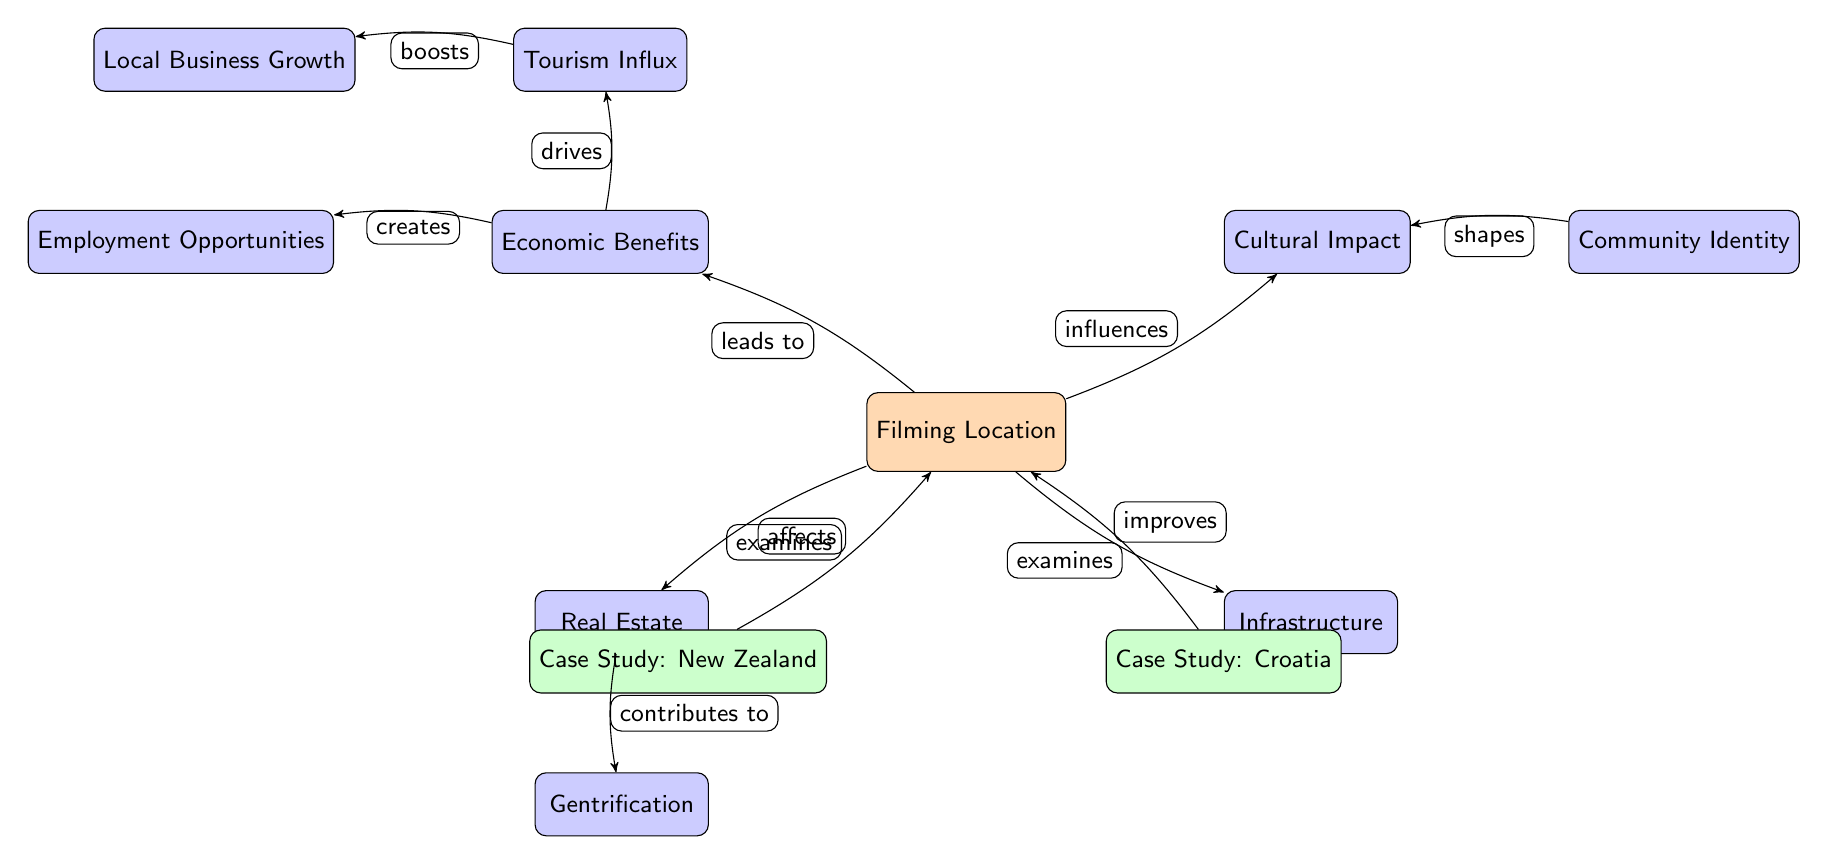What is the main node in this diagram? The main node represents the central theme or subject of the diagram, which is "Filming Location."
Answer: Filming Location How many case studies are present in the diagram? By counting the nodes labeled as case studies in the diagram, we find there are two: New Zealand and Croatia.
Answer: 2 What do filming locations influence according to the diagram? The diagram indicates that filming locations influence cultural aspects, specifically noted as "Cultural Impact."
Answer: Cultural Impact What is one economic benefit derived from filming locations? An economic benefit highlighted in the diagram is "Employment Opportunities," which is linked to the economic node.
Answer: Employment Opportunities Which node contributes to gentrification? The node titled "Real Estate" directly connects to the concept of gentrification, indicating that it contributes to this phenomenon.
Answer: Real Estate How does tourism impact local businesses? According to the diagram, tourism drives local business growth, demonstrating a positive influence of tourism on the local economy.
Answer: Boosts Describe the relationship between "Cultural Impact" and "Community Identity." The diagram shows that the nodes "Cultural Impact" and "Community Identity" are connected through a shaping relationship, indicating that community identity shapes cultural features within the community.
Answer: Shapes What is the relationship between filming locations and infrastructure? The diagram indicates that filming locations improve infrastructure, establishing a positive influence between the two concepts.
Answer: Improves Which case study examines the impact of filming locations? The diagram points out that both New Zealand and Croatia are labeled as case studies that examine the effects of filming locations.
Answer: New Zealand and Croatia 